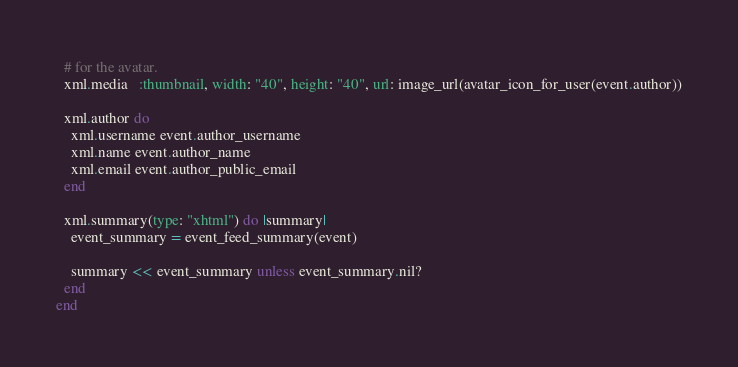<code> <loc_0><loc_0><loc_500><loc_500><_Ruby_>  # for the avatar.
  xml.media   :thumbnail, width: "40", height: "40", url: image_url(avatar_icon_for_user(event.author))

  xml.author do
    xml.username event.author_username
    xml.name event.author_name
    xml.email event.author_public_email
  end

  xml.summary(type: "xhtml") do |summary|
    event_summary = event_feed_summary(event)

    summary << event_summary unless event_summary.nil?
  end
end
</code> 